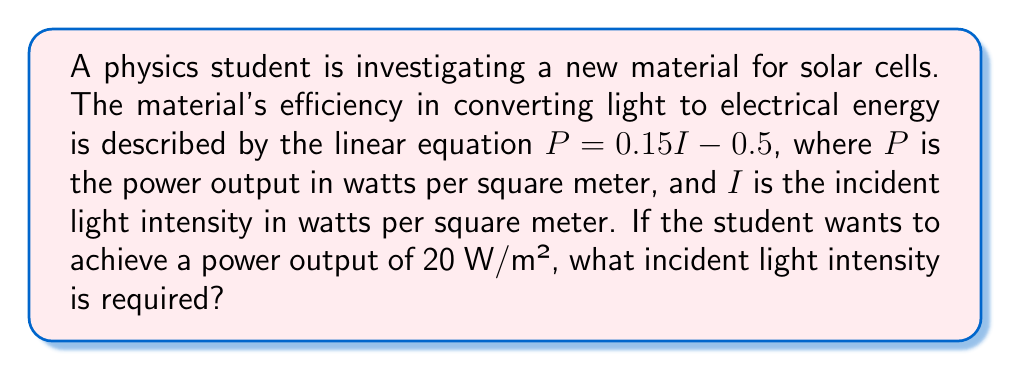Provide a solution to this math problem. To solve this problem, we need to use the given linear equation and substitute the desired power output to find the required incident light intensity. Let's follow these steps:

1) The given equation is:
   $$P = 0.15I - 0.5$$

2) We want to find $I$ when $P = 20$ W/m². Let's substitute this value:
   $$20 = 0.15I - 0.5$$

3) Now, we need to solve this equation for $I$. First, let's add 0.5 to both sides:
   $$20.5 = 0.15I$$

4) Then, divide both sides by 0.15:
   $$\frac{20.5}{0.15} = I$$

5) Calculate the result:
   $$I = 136.67 \text{ W/m²}$$

This means an incident light intensity of approximately 136.67 W/m² is required to achieve a power output of 20 W/m² with this solar cell material.
Answer: $136.67 \text{ W/m²}$ 